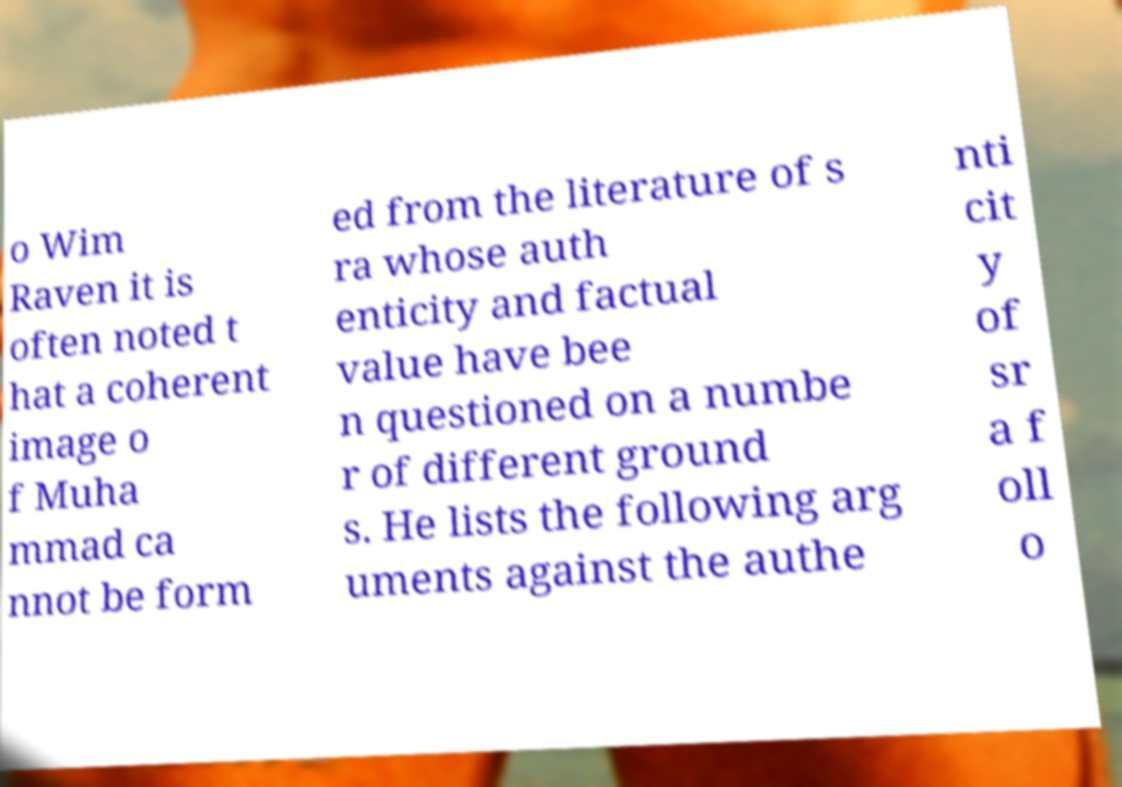Please read and relay the text visible in this image. What does it say? o Wim Raven it is often noted t hat a coherent image o f Muha mmad ca nnot be form ed from the literature of s ra whose auth enticity and factual value have bee n questioned on a numbe r of different ground s. He lists the following arg uments against the authe nti cit y of sr a f oll o 